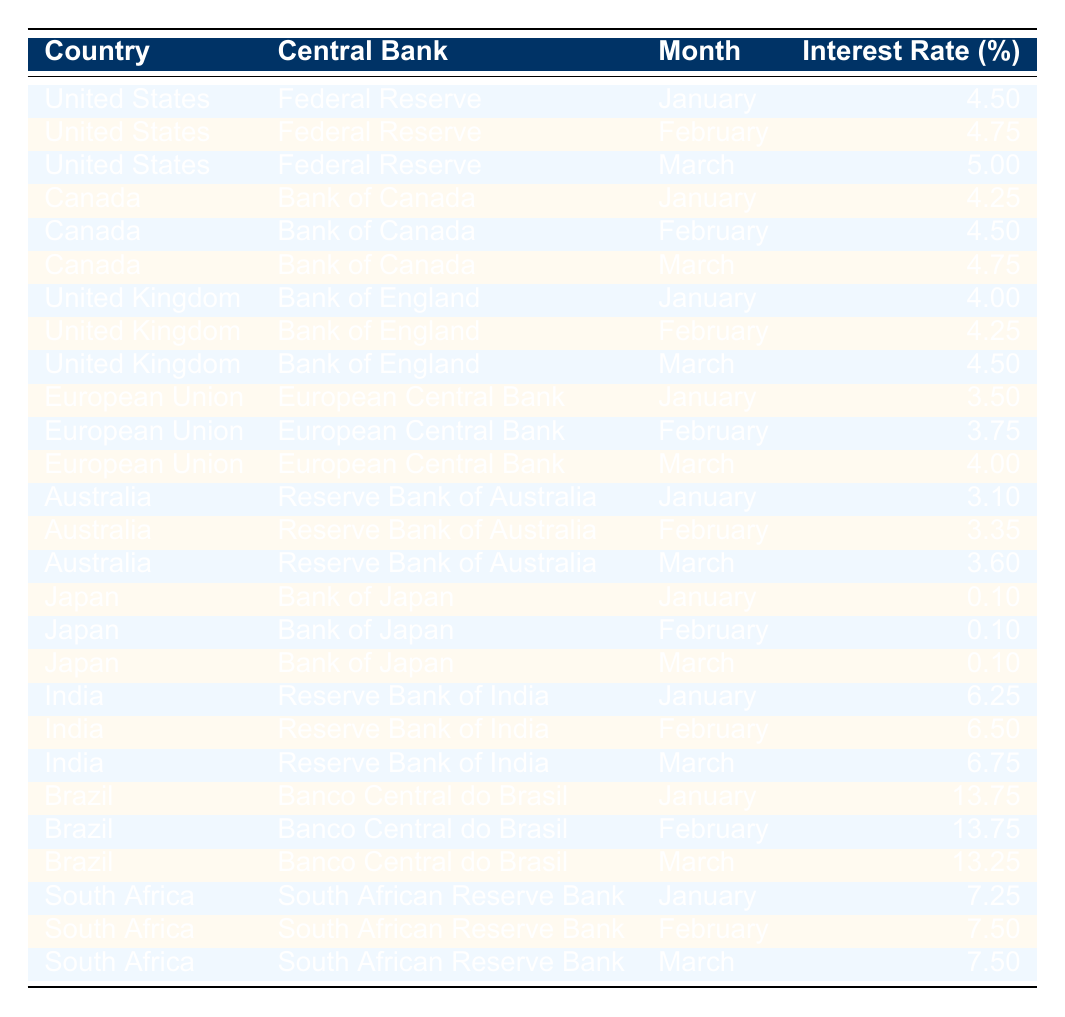What was the interest rate set by the Federal Reserve in January 2023? The table lists the interest rate for the Federal Reserve in January as 4.50%.
Answer: 4.50% Which country had the highest interest rate in March 2023? In March, Brazil had the highest interest rate at 13.25%.
Answer: Brazil What is the average interest rate for Canada over the first three months of 2023? The interest rates for Canada in January, February, and March are 4.25%, 4.50%, and 4.75%, respectively. To find the average, sum these rates (4.25 + 4.50 + 4.75 = 13.50) and divide by 3, which results in 13.50/3 = 4.50%.
Answer: 4.50% Did the Bank of Japan raise its interest rate in 2023? The interest rate set by the Bank of Japan was consistently 0.10% for all three months, indicating no increase.
Answer: No What was the difference between the interest rates in India from January to March 2023? The interest rates were 6.25% in January, 6.50% in February, and 6.75% in March. The difference from January to March is 6.75 - 6.25 = 0.50%.
Answer: 0.50% How much higher was the interest rate in Brazil in January compared to the European Union? Brazil had an interest rate of 13.75% in January, while the European Union had an interest rate of 3.50%. The difference is 13.75 - 3.50 = 10.25%.
Answer: 10.25% In which month did the United Kingdom have an interest rate of 4.50%? According to the table, the United Kingdom had an interest rate of 4.50% in March 2023.
Answer: March What is the total interest rate set by the Reserve Bank of Australia over the first quarter of 2023? The interest rates for the Reserve Bank of Australia in January, February, and March are 3.10%, 3.35%, and 3.60%. Summing these rates (3.10 + 3.35 + 3.60 = 10.05), the total is 10.05%.
Answer: 10.05% Which central bank increased its interest rate the most from January to March 2023? The Federal Reserve increased its interest rate from 4.50% to 5.00%, a total increase of 0.50%. Other banks’ rate increases were less.
Answer: Federal Reserve Was the interest rate for the Australian Reserve Bank lower, higher, or the same as Brazil's in February? In February, the Reserve Bank of Australia's rate was 3.35%, which is significantly lower than Brazil's 13.75%.
Answer: Lower 